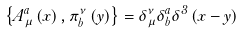Convert formula to latex. <formula><loc_0><loc_0><loc_500><loc_500>\left \{ A _ { \mu } ^ { a } \left ( x \right ) , \pi _ { b } ^ { \nu } \left ( y \right ) \right \} = \delta _ { \mu } ^ { \nu } \delta _ { b } ^ { a } \delta ^ { 3 } \left ( x - y \right )</formula> 